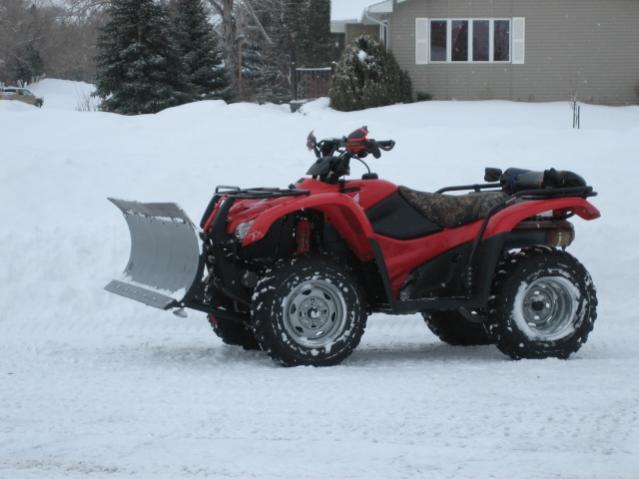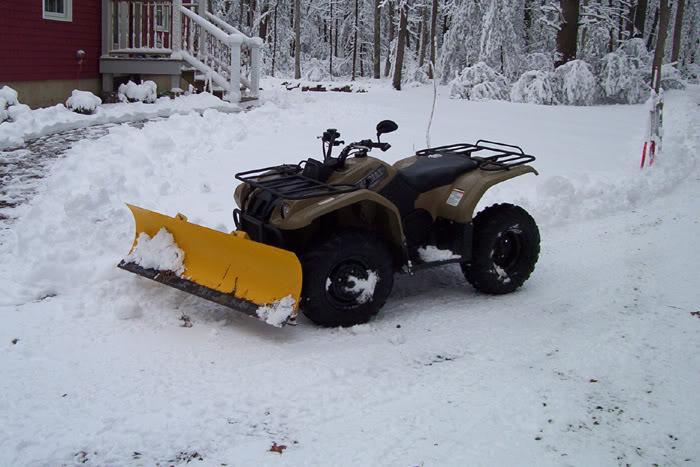The first image is the image on the left, the second image is the image on the right. For the images displayed, is the sentence "There are two 4 wheelers near houses." factually correct? Answer yes or no. Yes. 